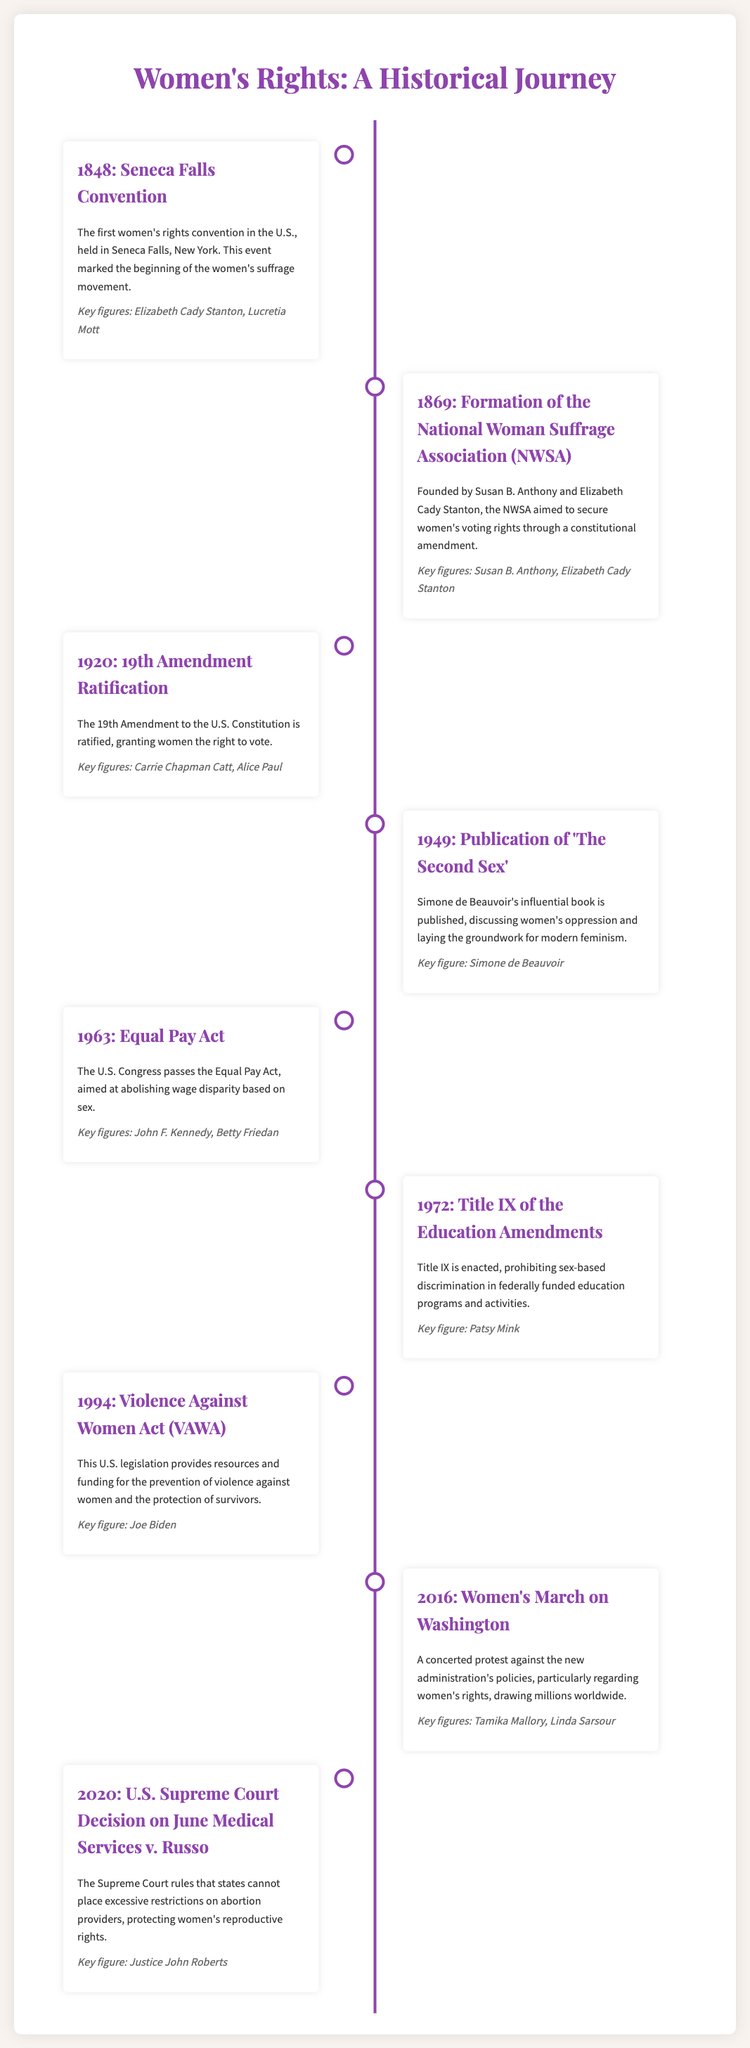What year was the Seneca Falls Convention held? The Seneca Falls Convention, marking the beginning of the women's suffrage movement, was held in 1848.
Answer: 1848 Who were the key figures in the formation of the National Woman Suffrage Association? The key figures in the formation of the National Woman Suffrage Association were Susan B. Anthony and Elizabeth Cady Stanton.
Answer: Susan B. Anthony, Elizabeth Cady Stanton What significant amendment was ratified in 1920? The 19th Amendment to the U.S. Constitution, granting women the right to vote, was ratified in 1920.
Answer: 19th Amendment Which book by Simone de Beauvoir discussed women's oppression? The book published by Simone de Beauvoir in 1949, which discusses women's oppression, is 'The Second Sex'.
Answer: The Second Sex What legislation was passed in 1963 to address wage disparity? The Equal Pay Act, aimed at abolishing wage disparity based on sex, was passed in 1963.
Answer: Equal Pay Act Who were the key figures associated with Title IX? The key figure associated with Title IX, enacted in 1972, is Patsy Mink.
Answer: Patsy Mink What event in 2016 was a protest against women's rights policies? The Women's March on Washington in 2016 was a concerted protest against women's rights policies.
Answer: Women's March on Washington What did the Supreme Court rule in the 2020 case of June Medical Services v. Russo? The Supreme Court ruled that states cannot place excessive restrictions on abortion providers in the 2020 case of June Medical Services v. Russo.
Answer: Excessive restrictions on abortion providers What is the primary focus of the Violence Against Women Act enacted in 1994? The primary focus of the Violence Against Women Act is to provide resources and funding for the prevention of violence against women and the protection of survivors.
Answer: Prevention of violence against women 